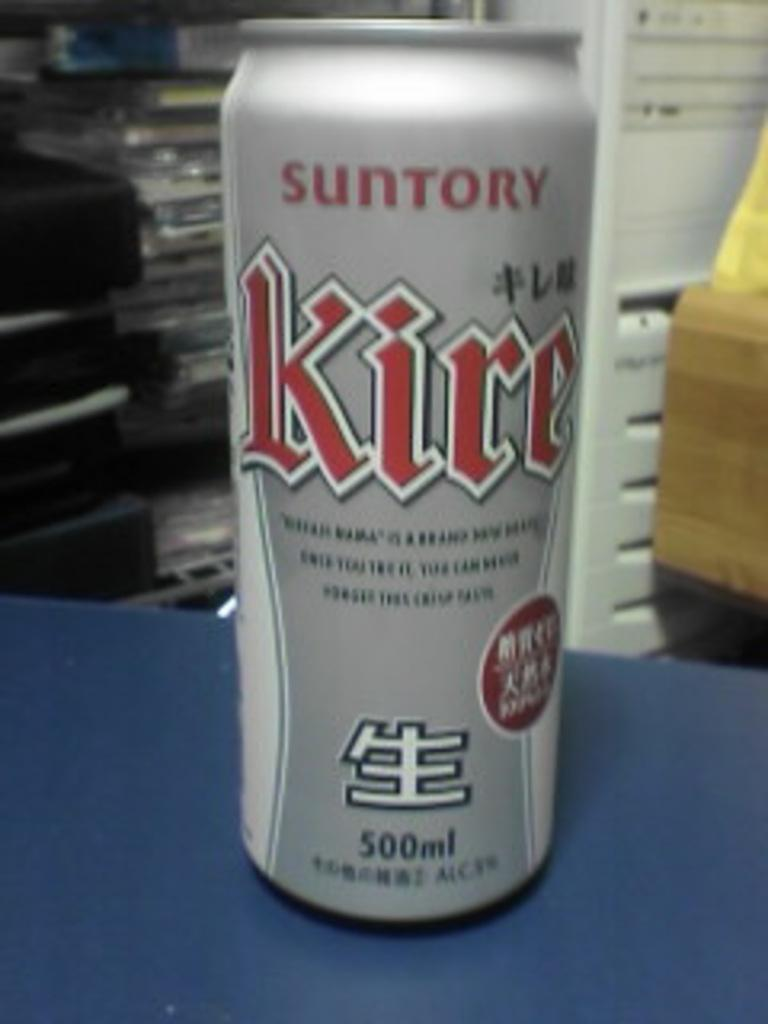<image>
Provide a brief description of the given image. The silver Kire can on the blue counter is 500ml. 